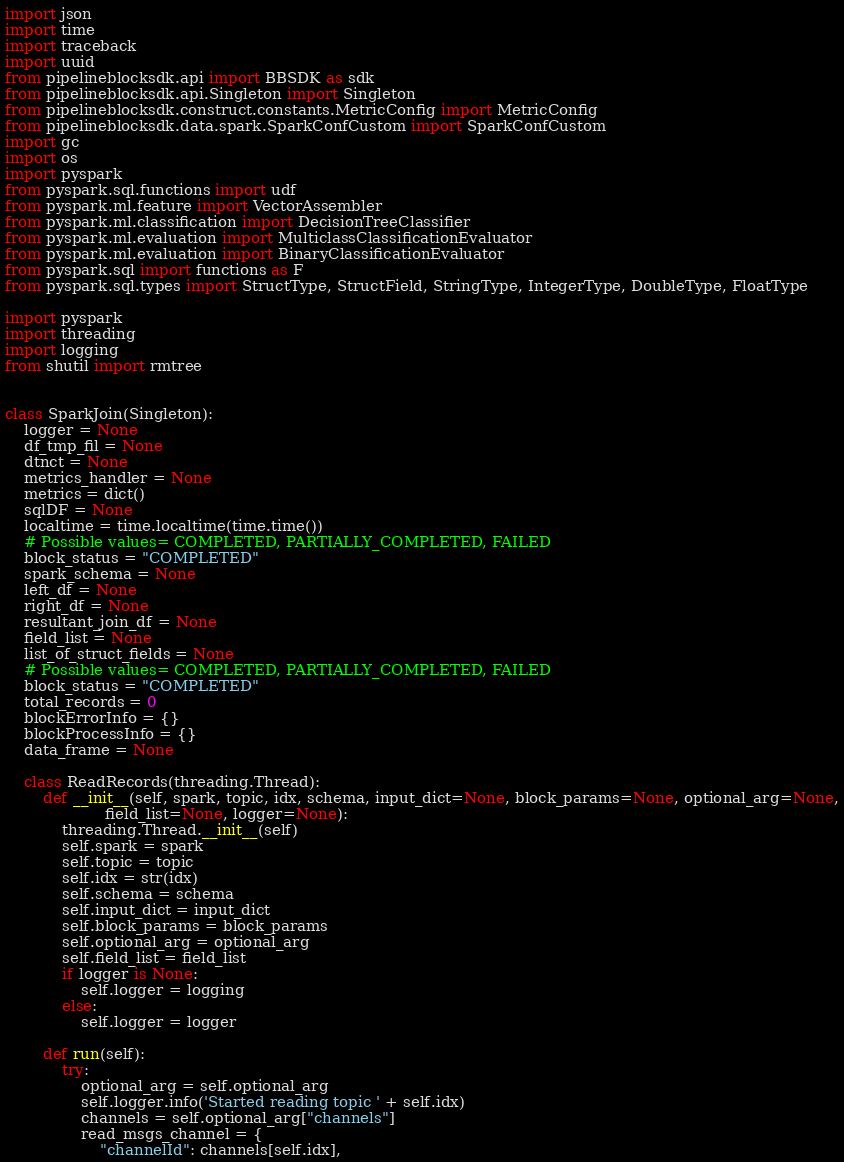<code> <loc_0><loc_0><loc_500><loc_500><_Python_>import json
import time
import traceback
import uuid
from pipelineblocksdk.api import BBSDK as sdk
from pipelineblocksdk.api.Singleton import Singleton
from pipelineblocksdk.construct.constants.MetricConfig import MetricConfig
from pipelineblocksdk.data.spark.SparkConfCustom import SparkConfCustom
import gc
import os
import pyspark
from pyspark.sql.functions import udf
from pyspark.ml.feature import VectorAssembler
from pyspark.ml.classification import DecisionTreeClassifier
from pyspark.ml.evaluation import MulticlassClassificationEvaluator
from pyspark.ml.evaluation import BinaryClassificationEvaluator
from pyspark.sql import functions as F
from pyspark.sql.types import StructType, StructField, StringType, IntegerType, DoubleType, FloatType

import pyspark
import threading
import logging
from shutil import rmtree


class SparkJoin(Singleton):
    logger = None
    df_tmp_fil = None
    dtnct = None
    metrics_handler = None
    metrics = dict()
    sqlDF = None
    localtime = time.localtime(time.time())
    # Possible values= COMPLETED, PARTIALLY_COMPLETED, FAILED
    block_status = "COMPLETED"
    spark_schema = None
    left_df = None
    right_df = None
    resultant_join_df = None
    field_list = None
    list_of_struct_fields = None
    # Possible values= COMPLETED, PARTIALLY_COMPLETED, FAILED
    block_status = "COMPLETED"
    total_records = 0
    blockErrorInfo = {}
    blockProcessInfo = {}
    data_frame = None

    class ReadRecords(threading.Thread):
        def __init__(self, spark, topic, idx, schema, input_dict=None, block_params=None, optional_arg=None,
                     field_list=None, logger=None):
            threading.Thread.__init__(self)
            self.spark = spark
            self.topic = topic
            self.idx = str(idx)
            self.schema = schema
            self.input_dict = input_dict
            self.block_params = block_params
            self.optional_arg = optional_arg
            self.field_list = field_list
            if logger is None:
                self.logger = logging
            else:
                self.logger = logger

        def run(self):
            try:
                optional_arg = self.optional_arg
                self.logger.info('Started reading topic ' + self.idx)
                channels = self.optional_arg["channels"]
                read_msgs_channel = {
                    "channelId": channels[self.idx],</code> 